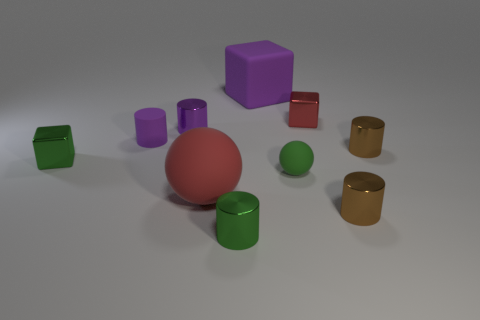Subtract all green cylinders. How many cylinders are left? 4 Subtract all brown blocks. How many purple cylinders are left? 2 Subtract 1 spheres. How many spheres are left? 1 Subtract all balls. How many objects are left? 8 Subtract all green balls. How many balls are left? 1 Subtract 1 brown cylinders. How many objects are left? 9 Subtract all yellow cubes. Subtract all red balls. How many cubes are left? 3 Subtract all large yellow matte cylinders. Subtract all small metallic objects. How many objects are left? 4 Add 3 large things. How many large things are left? 5 Add 1 red rubber things. How many red rubber things exist? 2 